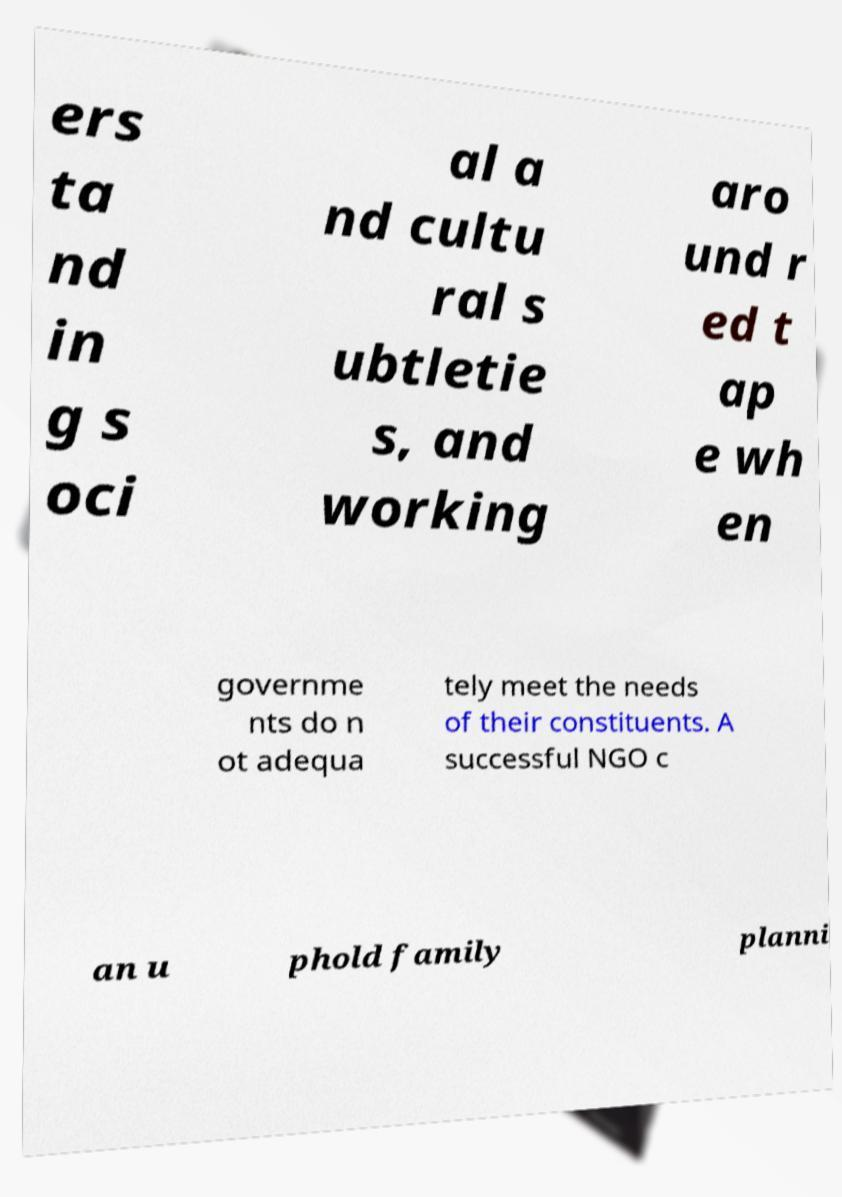There's text embedded in this image that I need extracted. Can you transcribe it verbatim? ers ta nd in g s oci al a nd cultu ral s ubtletie s, and working aro und r ed t ap e wh en governme nts do n ot adequa tely meet the needs of their constituents. A successful NGO c an u phold family planni 